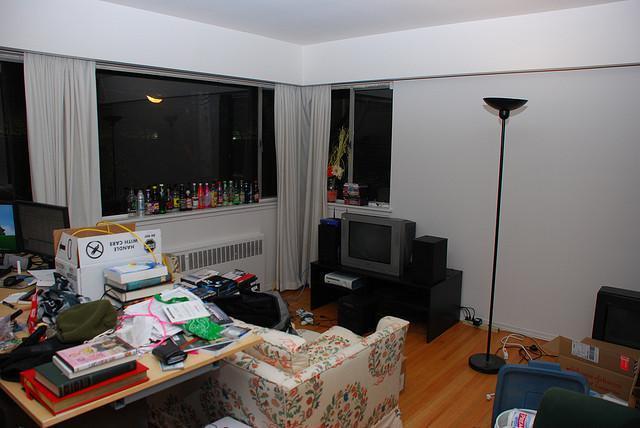How many lamps shades are there?
Give a very brief answer. 1. How many windows?
Give a very brief answer. 3. How many chairs are in the photo?
Give a very brief answer. 2. How many couches are visible?
Give a very brief answer. 2. 